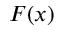<formula> <loc_0><loc_0><loc_500><loc_500>F ( x )</formula> 